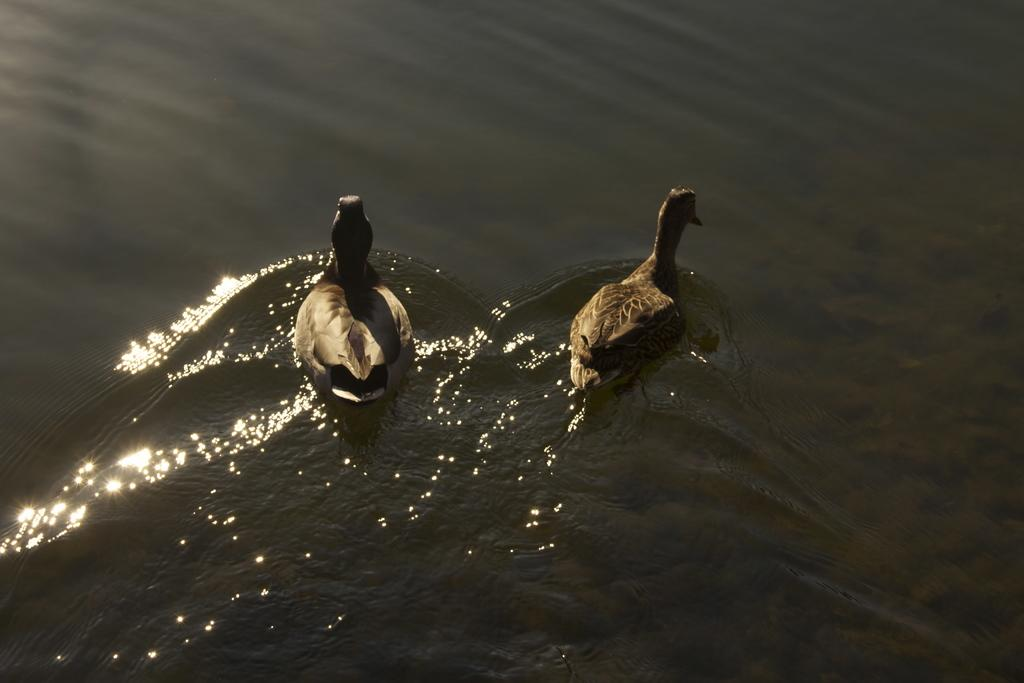What animals are present in the image? There are two ducks in the image. What is the ducks' location in relation to the water? The ducks are floating on the water. Reasoning: Let' Let's think step by step in order to produce the conversation. We start by identifying the main subjects in the image, which are the two ducks. Then, we describe their location and activity, which is floating on the water. Each question is designed to elicit a specific detail about the image that is known from the provided facts. Absurd Question/Answer: What is the level of disgust expressed by the ducks in the image? There is no indication of any emotion, including disgust, expressed by the ducks in the image. 